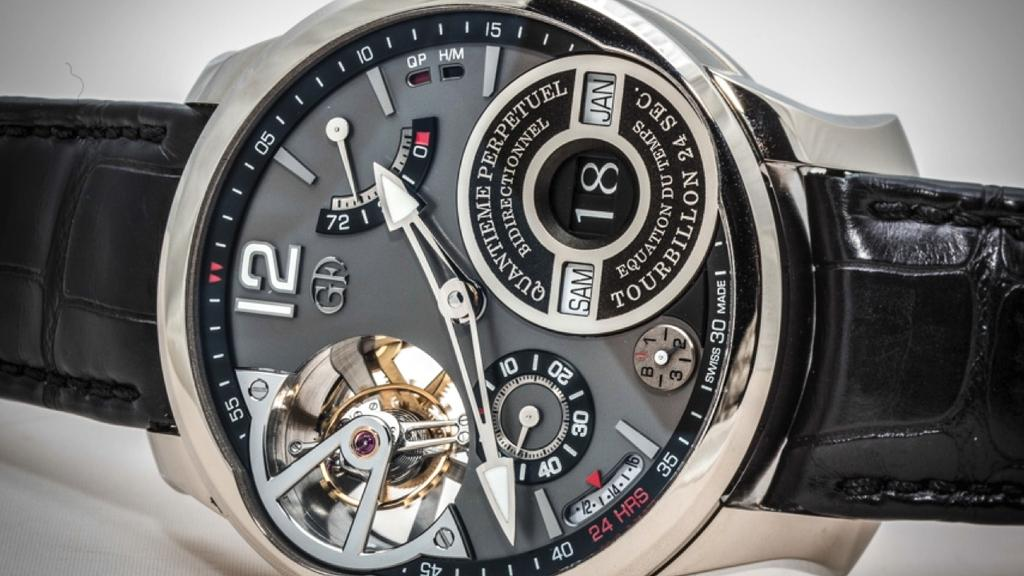<image>
Summarize the visual content of the image. A watch with a black strap that indicates the time is 1:41. 